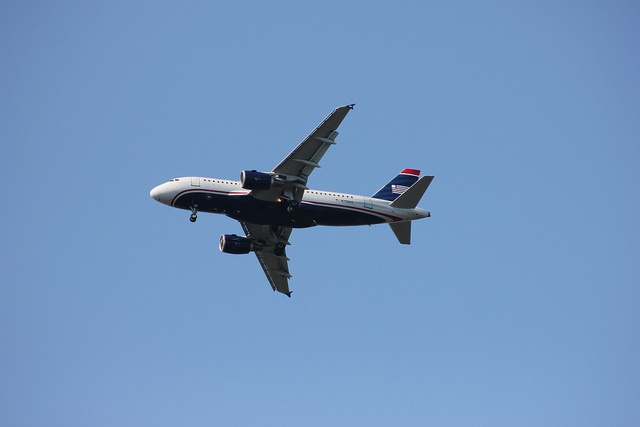Describe the objects in this image and their specific colors. I can see a airplane in gray, black, darkgray, and lightgray tones in this image. 